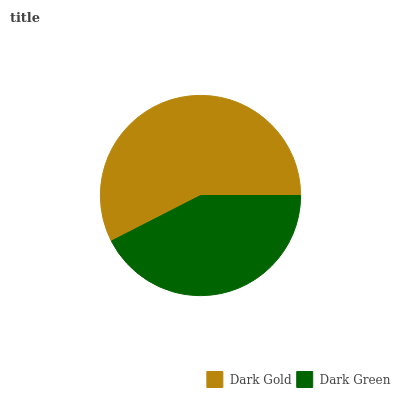Is Dark Green the minimum?
Answer yes or no. Yes. Is Dark Gold the maximum?
Answer yes or no. Yes. Is Dark Green the maximum?
Answer yes or no. No. Is Dark Gold greater than Dark Green?
Answer yes or no. Yes. Is Dark Green less than Dark Gold?
Answer yes or no. Yes. Is Dark Green greater than Dark Gold?
Answer yes or no. No. Is Dark Gold less than Dark Green?
Answer yes or no. No. Is Dark Gold the high median?
Answer yes or no. Yes. Is Dark Green the low median?
Answer yes or no. Yes. Is Dark Green the high median?
Answer yes or no. No. Is Dark Gold the low median?
Answer yes or no. No. 